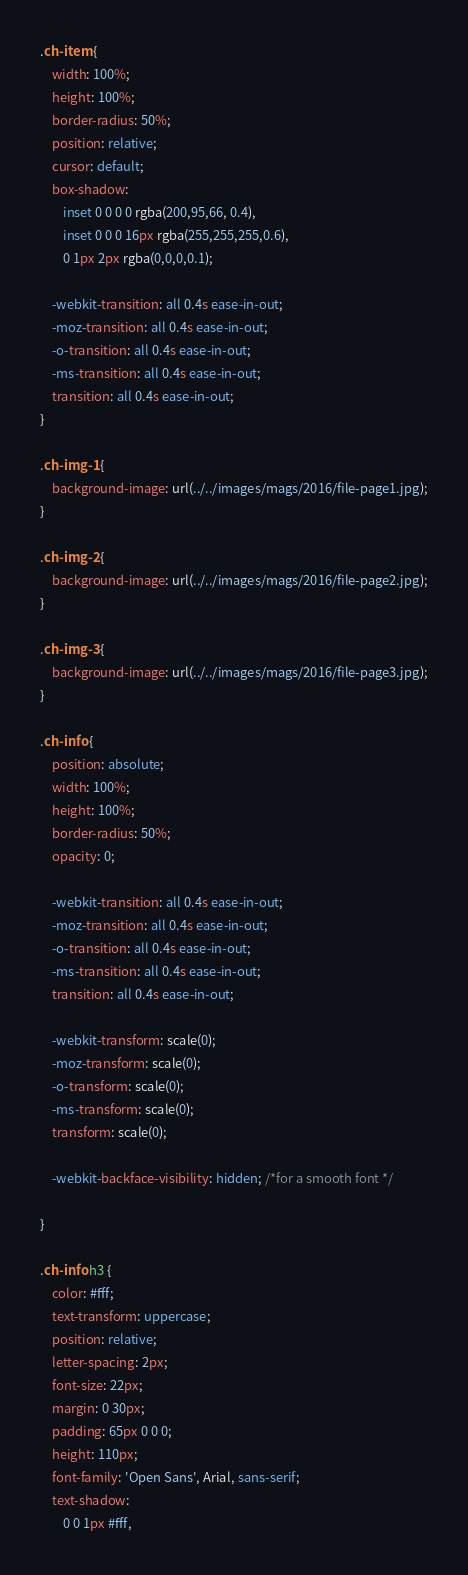Convert code to text. <code><loc_0><loc_0><loc_500><loc_500><_CSS_>.ch-item {
	width: 100%;
	height: 100%;
	border-radius: 50%;
	position: relative;
	cursor: default;
	box-shadow: 
		inset 0 0 0 0 rgba(200,95,66, 0.4),
		inset 0 0 0 16px rgba(255,255,255,0.6),
		0 1px 2px rgba(0,0,0,0.1);
		
	-webkit-transition: all 0.4s ease-in-out;
	-moz-transition: all 0.4s ease-in-out;
	-o-transition: all 0.4s ease-in-out;
	-ms-transition: all 0.4s ease-in-out;
	transition: all 0.4s ease-in-out;
}

.ch-img-1 { 
	background-image: url(../../images/mags/2016/file-page1.jpg);
}

.ch-img-2 { 
	background-image: url(../../images/mags/2016/file-page2.jpg);
}

.ch-img-3 { 
	background-image: url(../../images/mags/2016/file-page3.jpg);
}

.ch-info {
	position: absolute;
	width: 100%;
	height: 100%;
	border-radius: 50%;
	opacity: 0;
	
	-webkit-transition: all 0.4s ease-in-out;
	-moz-transition: all 0.4s ease-in-out;
	-o-transition: all 0.4s ease-in-out;
	-ms-transition: all 0.4s ease-in-out;
	transition: all 0.4s ease-in-out;
	
	-webkit-transform: scale(0);
	-moz-transform: scale(0);
	-o-transform: scale(0);
	-ms-transform: scale(0);
	transform: scale(0);
	
	-webkit-backface-visibility: hidden; /*for a smooth font */

}

.ch-info h3 {
	color: #fff;
	text-transform: uppercase;
	position: relative;
	letter-spacing: 2px;
	font-size: 22px;
	margin: 0 30px;
	padding: 65px 0 0 0;
	height: 110px;
	font-family: 'Open Sans', Arial, sans-serif;
	text-shadow: 
		0 0 1px #fff, </code> 